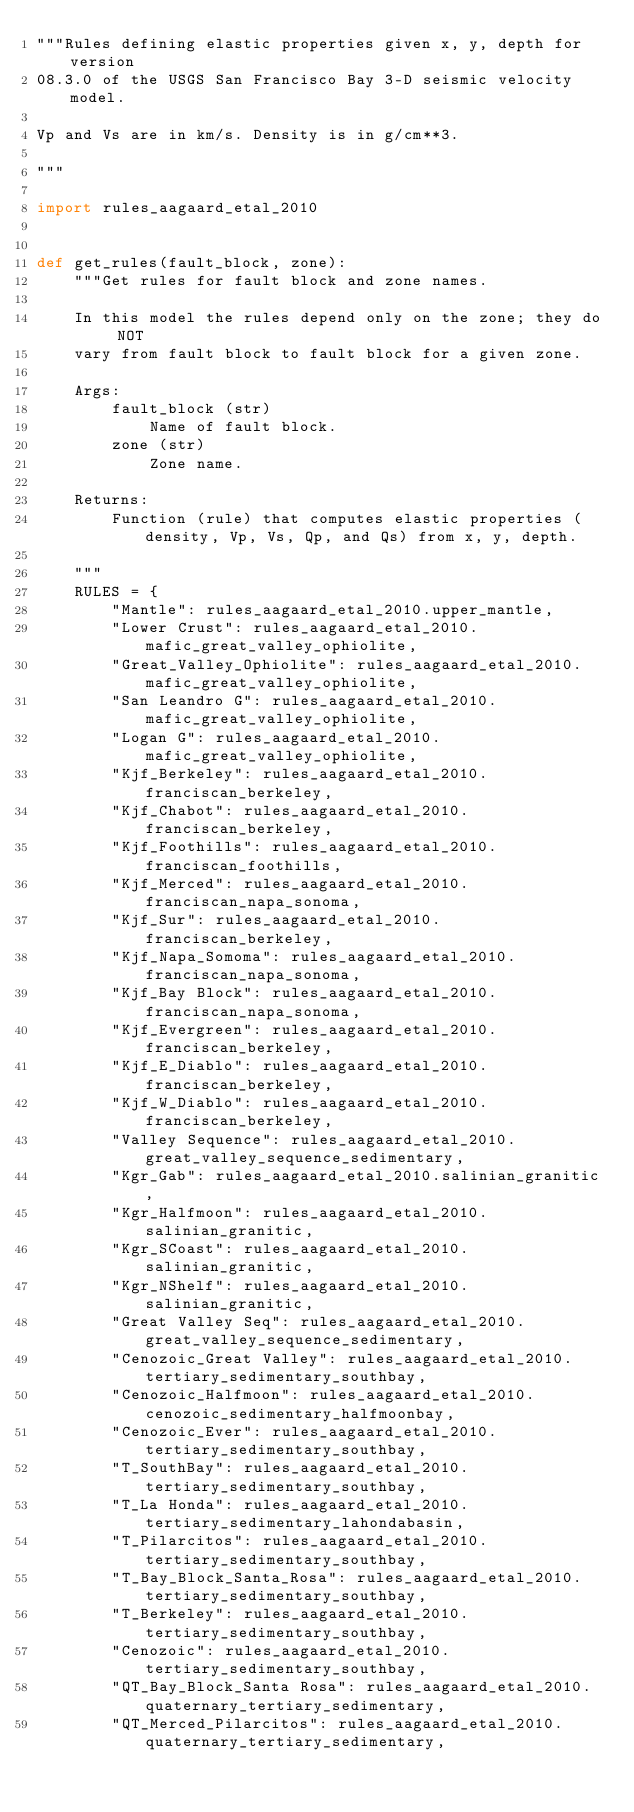Convert code to text. <code><loc_0><loc_0><loc_500><loc_500><_Python_>"""Rules defining elastic properties given x, y, depth for version
08.3.0 of the USGS San Francisco Bay 3-D seismic velocity model.

Vp and Vs are in km/s. Density is in g/cm**3.

"""

import rules_aagaard_etal_2010


def get_rules(fault_block, zone):
    """Get rules for fault block and zone names.

    In this model the rules depend only on the zone; they do NOT
    vary from fault block to fault block for a given zone.

    Args:
        fault_block (str)
            Name of fault block.
        zone (str)
            Zone name.

    Returns:
        Function (rule) that computes elastic properties (density, Vp, Vs, Qp, and Qs) from x, y, depth.

    """
    RULES = {
        "Mantle": rules_aagaard_etal_2010.upper_mantle,
        "Lower Crust": rules_aagaard_etal_2010.mafic_great_valley_ophiolite,
        "Great_Valley_Ophiolite": rules_aagaard_etal_2010.mafic_great_valley_ophiolite,
        "San Leandro G": rules_aagaard_etal_2010.mafic_great_valley_ophiolite,
        "Logan G": rules_aagaard_etal_2010.mafic_great_valley_ophiolite,
        "Kjf_Berkeley": rules_aagaard_etal_2010.franciscan_berkeley,
        "Kjf_Chabot": rules_aagaard_etal_2010.franciscan_berkeley,
        "Kjf_Foothills": rules_aagaard_etal_2010.franciscan_foothills,
        "Kjf_Merced": rules_aagaard_etal_2010.franciscan_napa_sonoma,
        "Kjf_Sur": rules_aagaard_etal_2010.franciscan_berkeley,
        "Kjf_Napa_Somoma": rules_aagaard_etal_2010.franciscan_napa_sonoma,
        "Kjf_Bay Block": rules_aagaard_etal_2010.franciscan_napa_sonoma,
        "Kjf_Evergreen": rules_aagaard_etal_2010.franciscan_berkeley,
        "Kjf_E_Diablo": rules_aagaard_etal_2010.franciscan_berkeley,
        "Kjf_W_Diablo": rules_aagaard_etal_2010.franciscan_berkeley,
        "Valley Sequence": rules_aagaard_etal_2010.great_valley_sequence_sedimentary,
        "Kgr_Gab": rules_aagaard_etal_2010.salinian_granitic,
        "Kgr_Halfmoon": rules_aagaard_etal_2010.salinian_granitic,
        "Kgr_SCoast": rules_aagaard_etal_2010.salinian_granitic,
        "Kgr_NShelf": rules_aagaard_etal_2010.salinian_granitic,
        "Great Valley Seq": rules_aagaard_etal_2010.great_valley_sequence_sedimentary,
        "Cenozoic_Great Valley": rules_aagaard_etal_2010.tertiary_sedimentary_southbay,
        "Cenozoic_Halfmoon": rules_aagaard_etal_2010.cenozoic_sedimentary_halfmoonbay,
        "Cenozoic_Ever": rules_aagaard_etal_2010.tertiary_sedimentary_southbay,
        "T_SouthBay": rules_aagaard_etal_2010.tertiary_sedimentary_southbay,
        "T_La Honda": rules_aagaard_etal_2010.tertiary_sedimentary_lahondabasin,
        "T_Pilarcitos": rules_aagaard_etal_2010.tertiary_sedimentary_southbay,
        "T_Bay_Block_Santa_Rosa": rules_aagaard_etal_2010.tertiary_sedimentary_southbay,
        "T_Berkeley": rules_aagaard_etal_2010.tertiary_sedimentary_southbay,
        "Cenozoic": rules_aagaard_etal_2010.tertiary_sedimentary_southbay,
        "QT_Bay_Block_Santa Rosa": rules_aagaard_etal_2010.quaternary_tertiary_sedimentary,
        "QT_Merced_Pilarcitos": rules_aagaard_etal_2010.quaternary_tertiary_sedimentary,</code> 